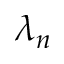Convert formula to latex. <formula><loc_0><loc_0><loc_500><loc_500>\lambda _ { n }</formula> 